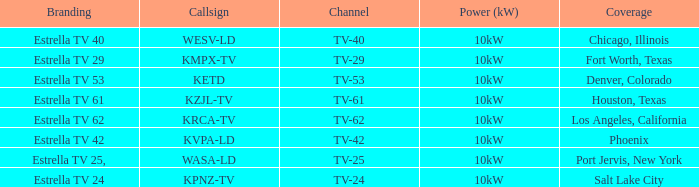Itemize the energy production for phoenix. 10kW. 